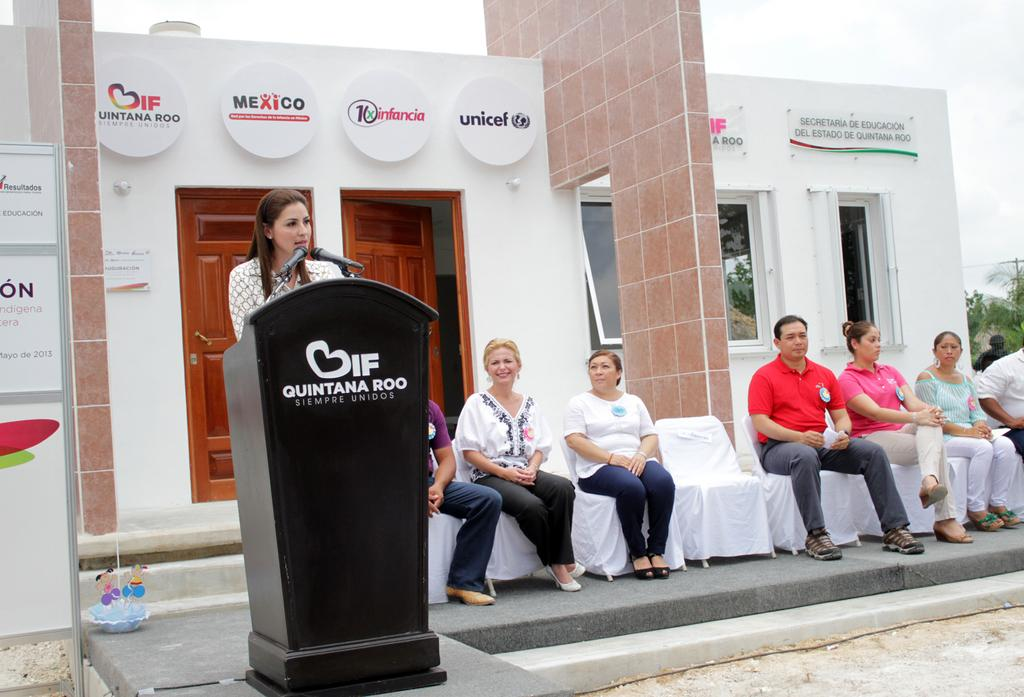<image>
Relay a brief, clear account of the picture shown. Woman speaking in front of a podium that says QUINTANA ROO. 